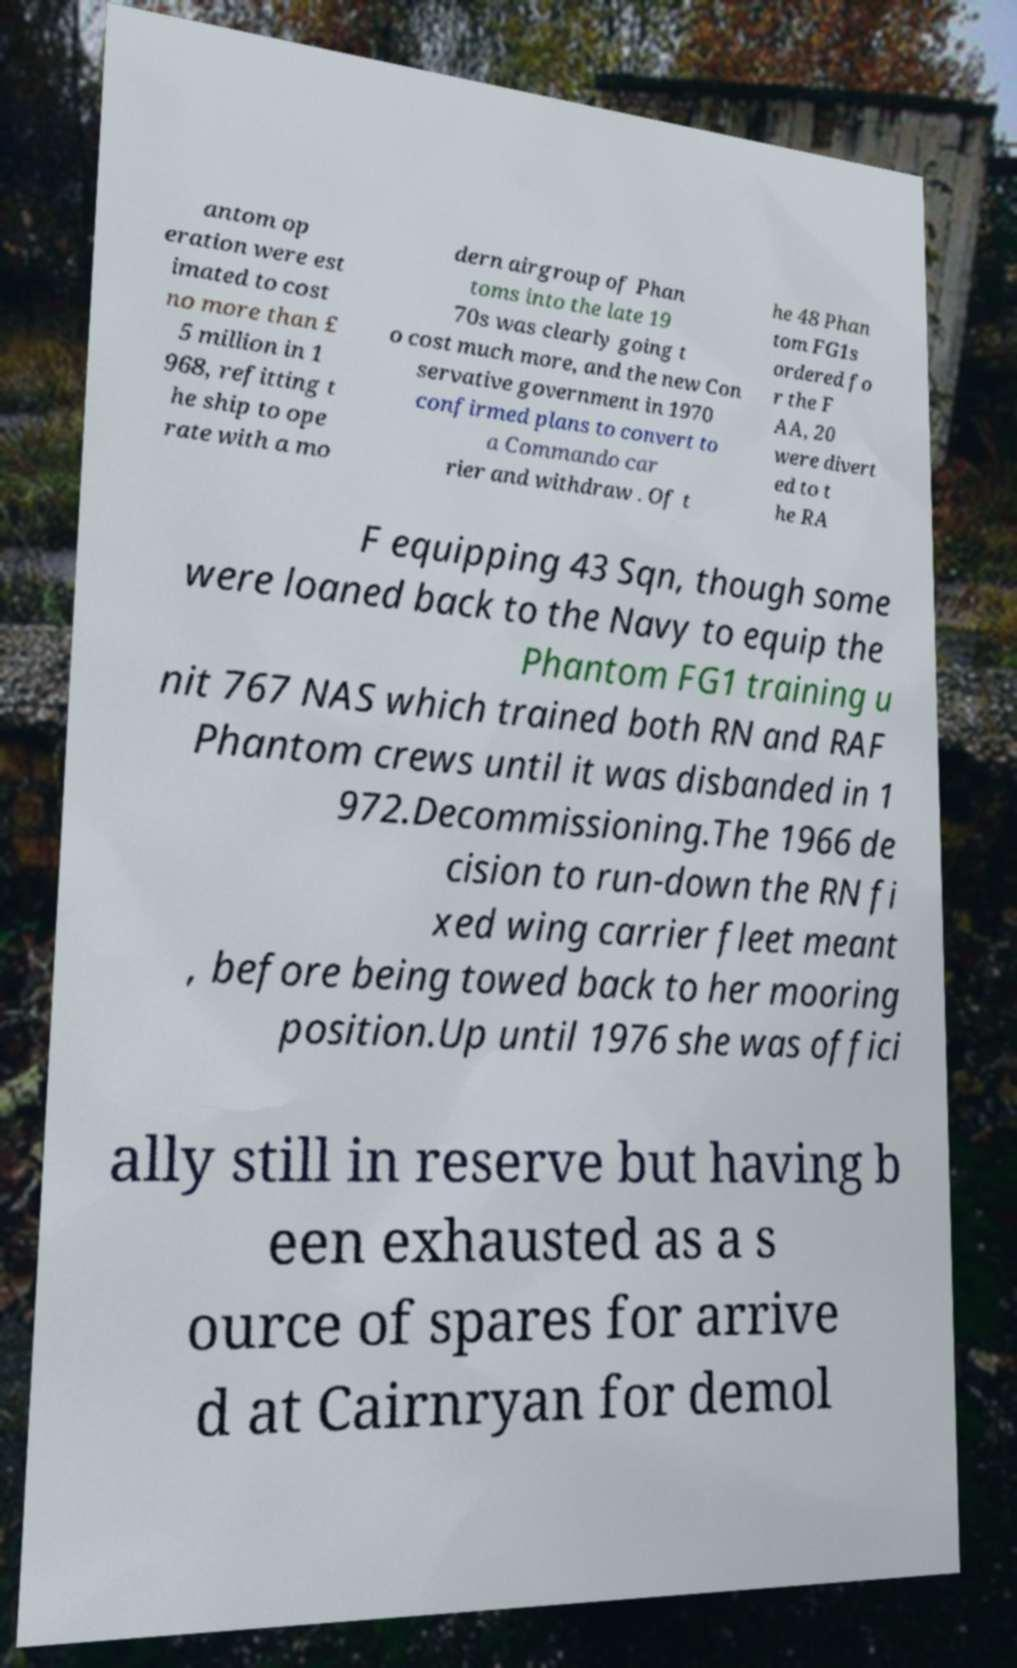Could you extract and type out the text from this image? antom op eration were est imated to cost no more than £ 5 million in 1 968, refitting t he ship to ope rate with a mo dern airgroup of Phan toms into the late 19 70s was clearly going t o cost much more, and the new Con servative government in 1970 confirmed plans to convert to a Commando car rier and withdraw . Of t he 48 Phan tom FG1s ordered fo r the F AA, 20 were divert ed to t he RA F equipping 43 Sqn, though some were loaned back to the Navy to equip the Phantom FG1 training u nit 767 NAS which trained both RN and RAF Phantom crews until it was disbanded in 1 972.Decommissioning.The 1966 de cision to run-down the RN fi xed wing carrier fleet meant , before being towed back to her mooring position.Up until 1976 she was offici ally still in reserve but having b een exhausted as a s ource of spares for arrive d at Cairnryan for demol 